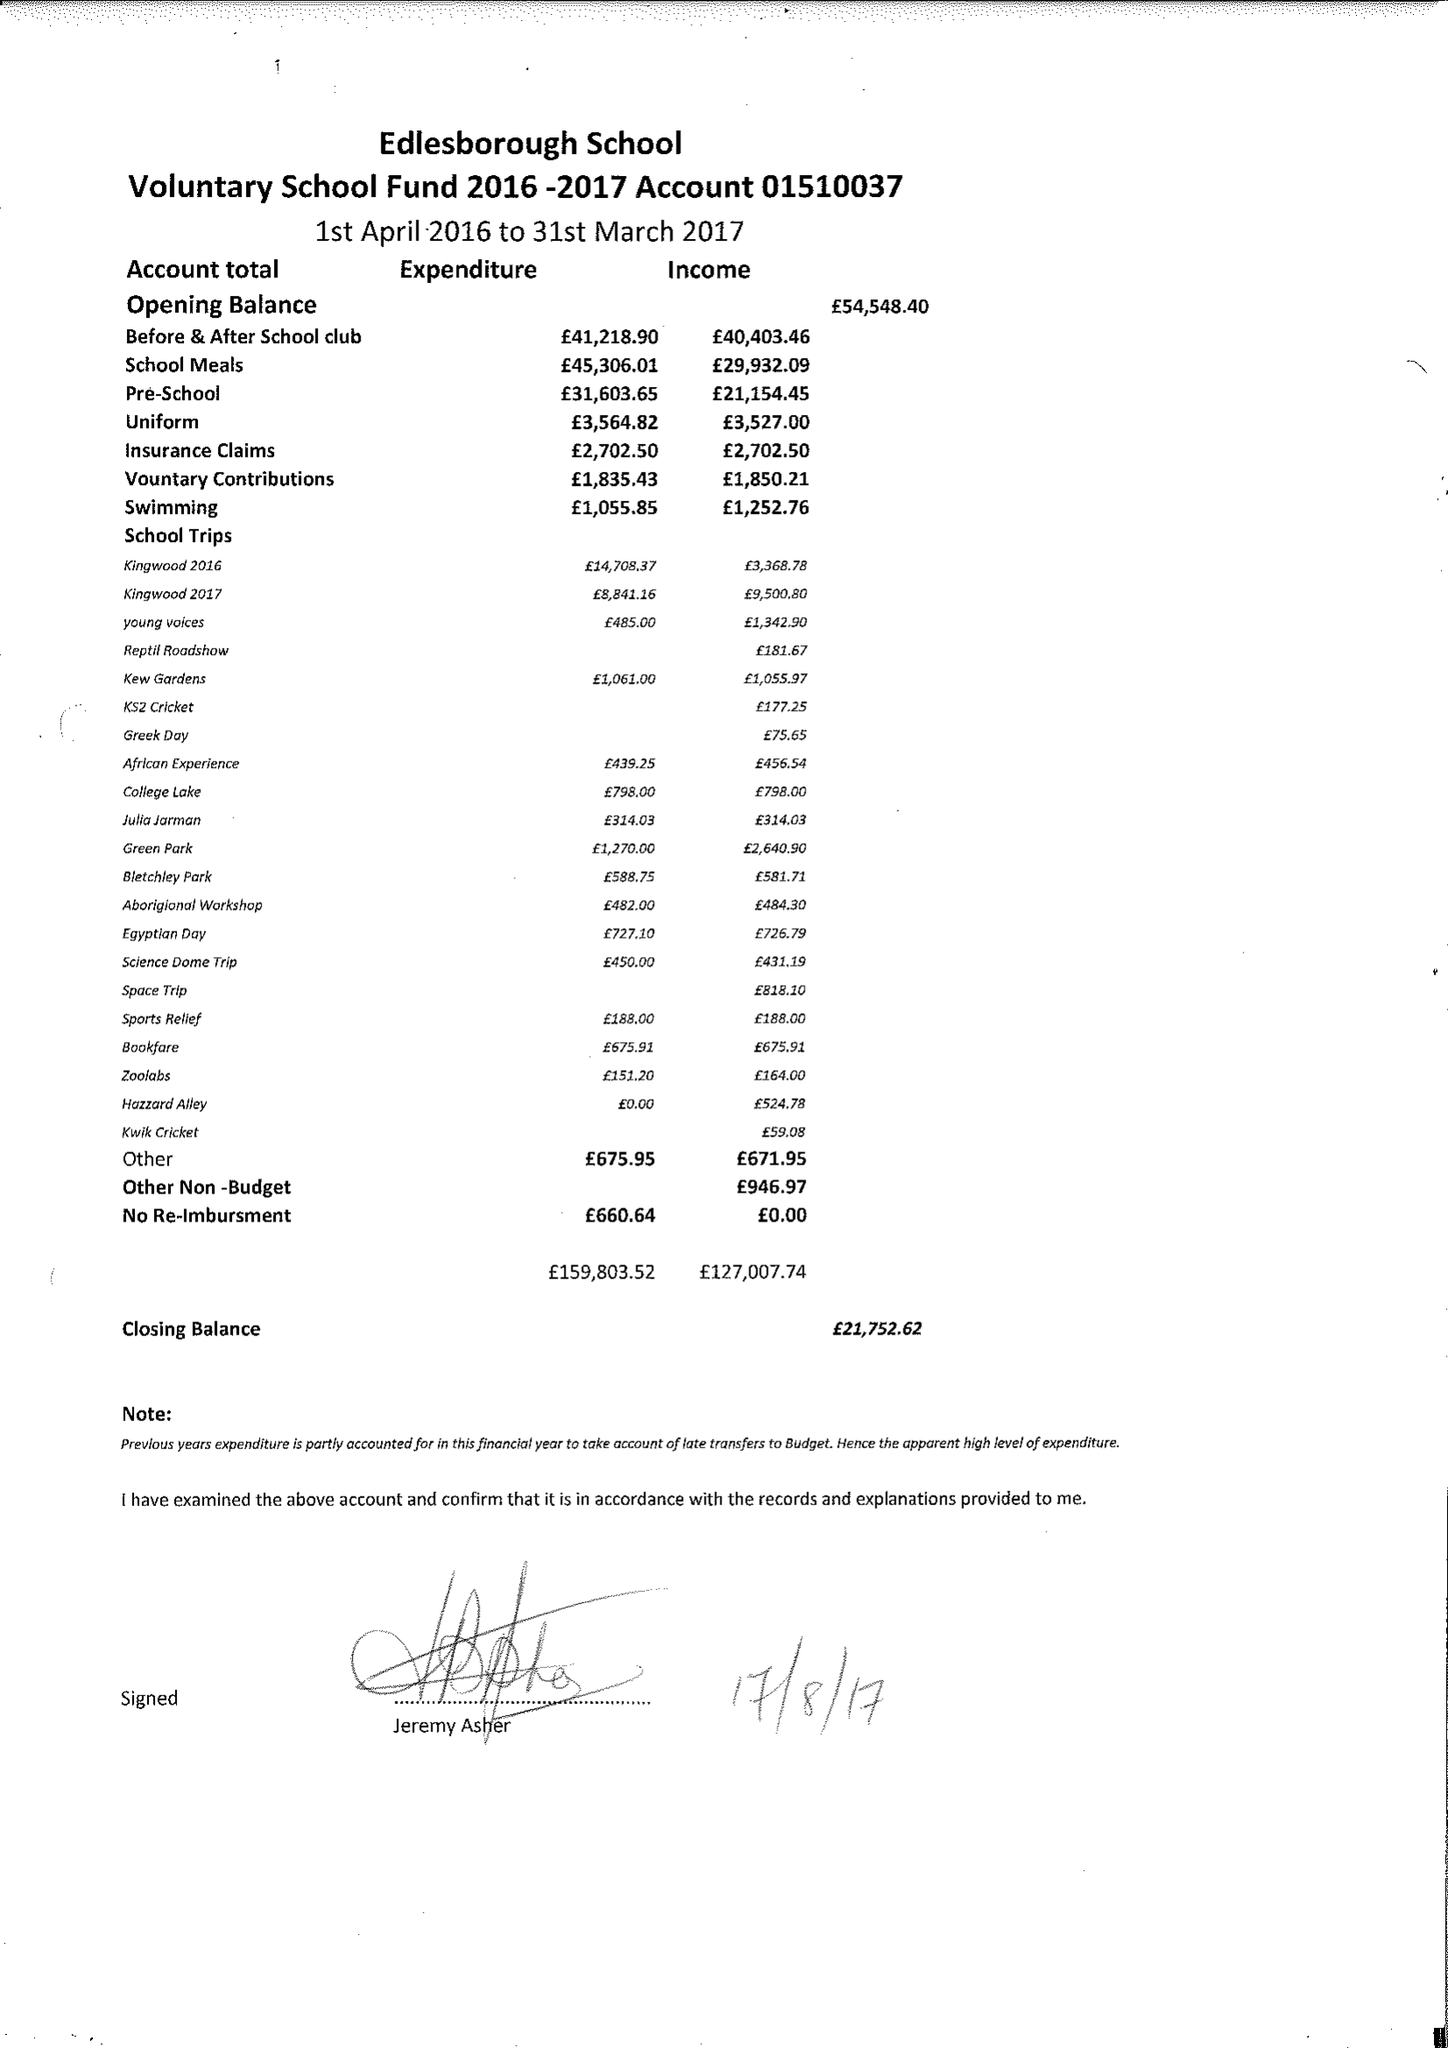What is the value for the charity_number?
Answer the question using a single word or phrase. 1067917 